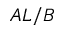Convert formula to latex. <formula><loc_0><loc_0><loc_500><loc_500>A L / B</formula> 